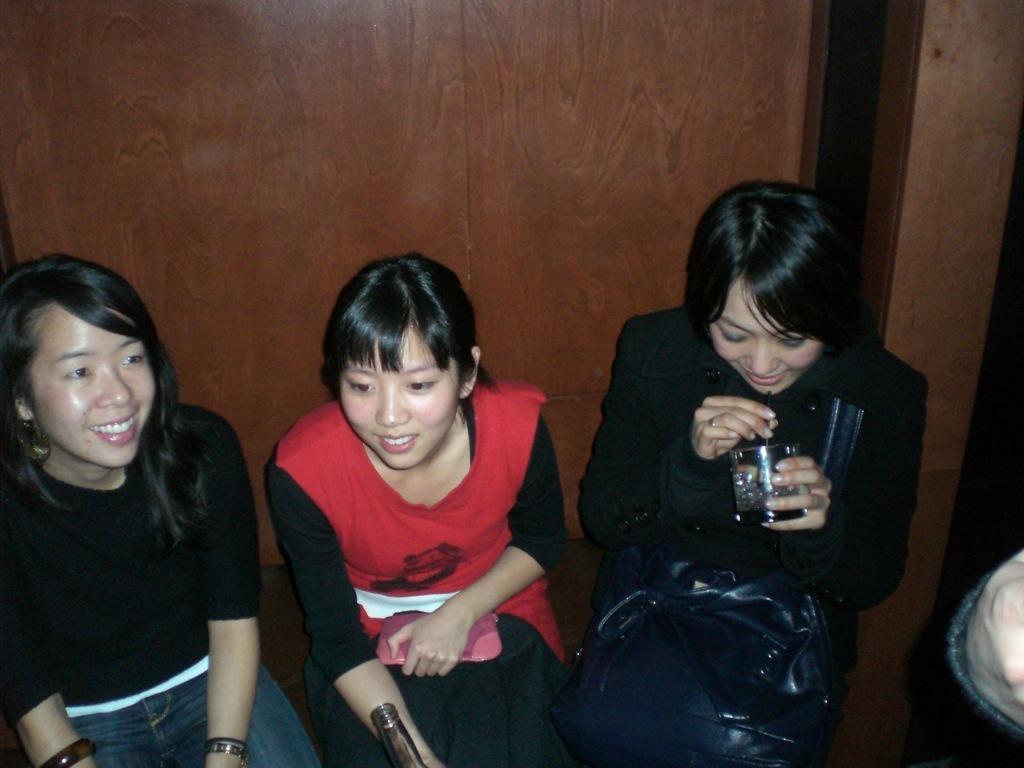Describe this image in one or two sentences. In this image there are three women sitting towards the bottom of the image, there is a woman holding an object, there is a woman holding a glass, there is a bottle towards the bottom of the image, there is a person's hand towards the right of the image, at the background of the image there is a wooden wall. 